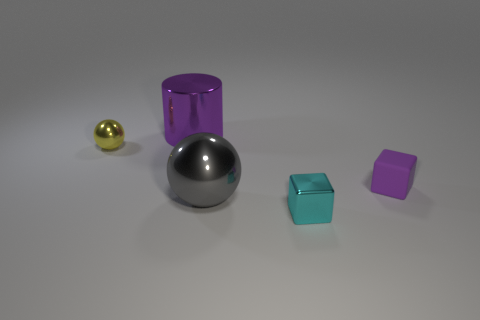Add 4 small green things. How many objects exist? 9 Subtract all cylinders. How many objects are left? 4 Subtract all green blocks. Subtract all brown spheres. How many blocks are left? 2 Subtract all gray cylinders. How many gray balls are left? 1 Subtract all red metal cubes. Subtract all small cyan shiny things. How many objects are left? 4 Add 4 shiny balls. How many shiny balls are left? 6 Add 5 small red cylinders. How many small red cylinders exist? 5 Subtract 0 blue spheres. How many objects are left? 5 Subtract 1 blocks. How many blocks are left? 1 